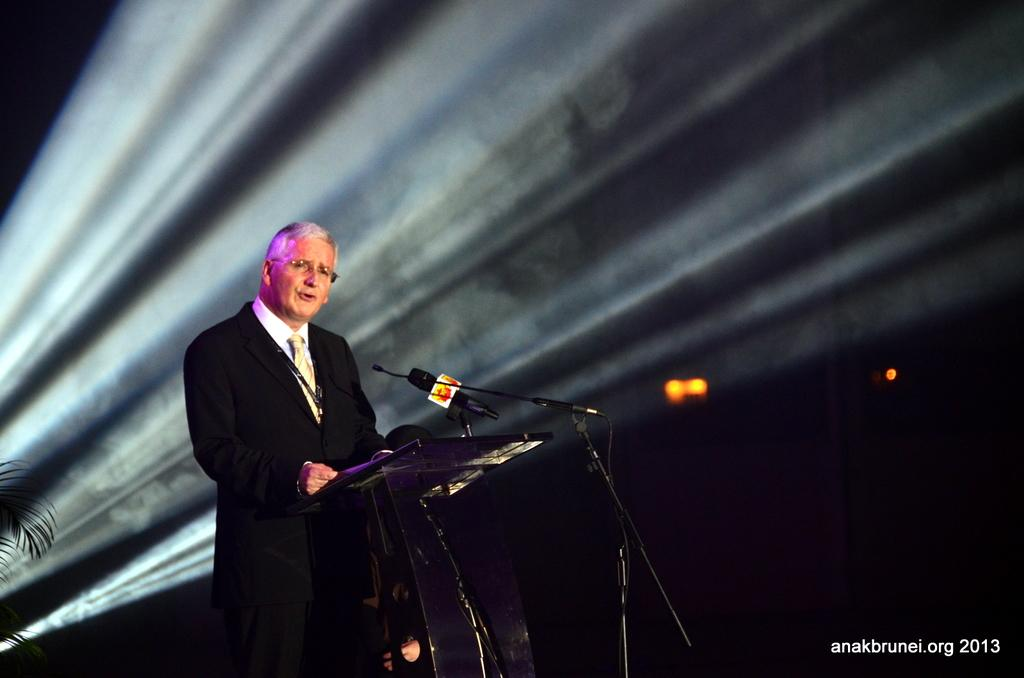What is the person in the image doing? The person is standing at a lectern in the image. What is the person holding while standing at the lectern? The person is holding a mic. What can be seen in the background of the image? There are lights and a tree visible in the background of the image. What is the person's tendency to regret in the image? There is no indication of the person's feelings or emotions in the image, so it is not possible to determine their tendency to regret. 